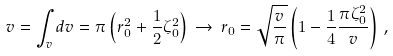<formula> <loc_0><loc_0><loc_500><loc_500>v = \int _ { v } d v = \pi \left ( r _ { 0 } ^ { 2 } + \frac { 1 } { 2 } \zeta _ { 0 } ^ { 2 } \right ) \, \rightarrow \, r _ { 0 } = \sqrt { \frac { v } { \pi } } \left ( 1 - \frac { 1 } { 4 } \frac { \pi \zeta _ { 0 } ^ { 2 } } { v } \right ) \, ,</formula> 